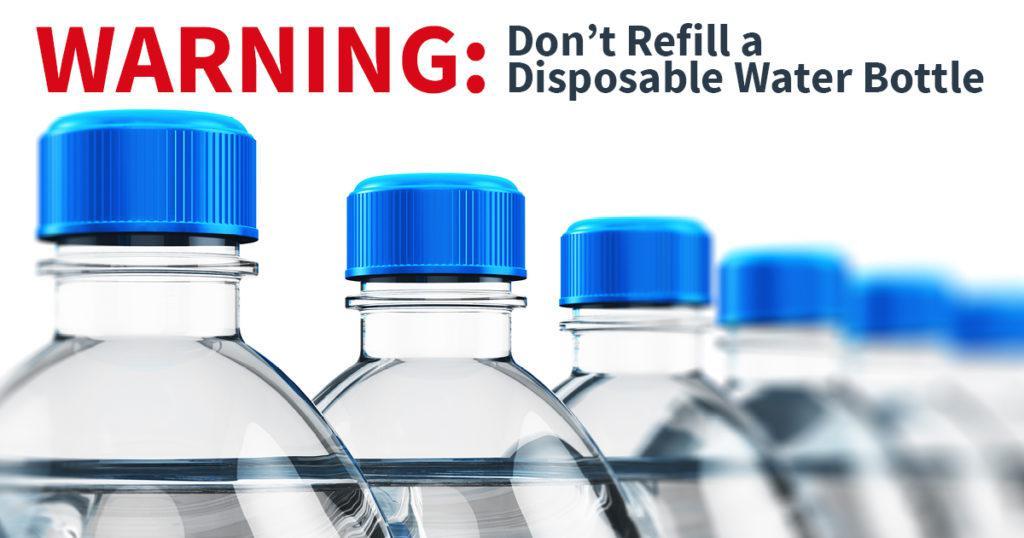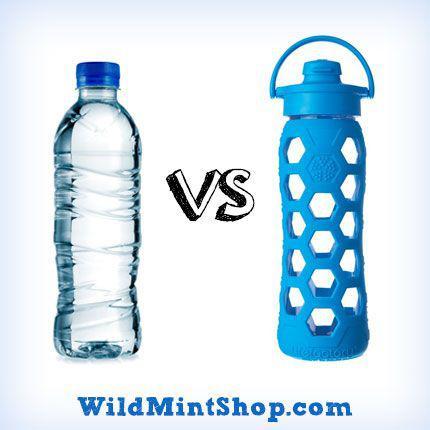The first image is the image on the left, the second image is the image on the right. For the images shown, is this caption "The bottles in one image clearly have labels, the bottles in the other clearly do not." true? Answer yes or no. No. The first image is the image on the left, the second image is the image on the right. For the images shown, is this caption "One image shows a row of water bottles with white caps and no labels, and the other image shows a variety of water bottle shapes and labels in an overlapping arrangement." true? Answer yes or no. No. 